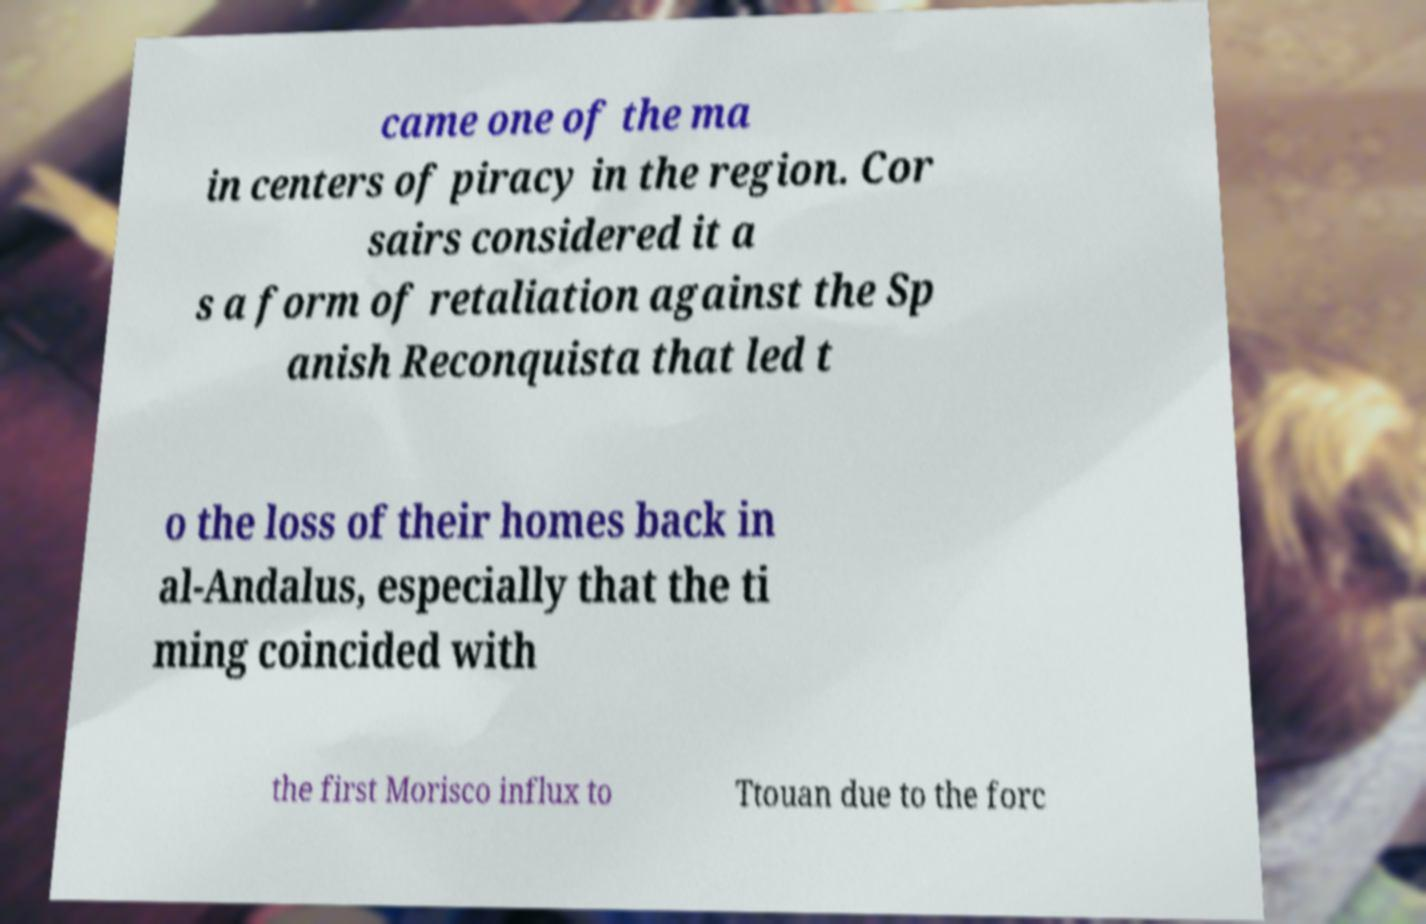Can you read and provide the text displayed in the image?This photo seems to have some interesting text. Can you extract and type it out for me? came one of the ma in centers of piracy in the region. Cor sairs considered it a s a form of retaliation against the Sp anish Reconquista that led t o the loss of their homes back in al-Andalus, especially that the ti ming coincided with the first Morisco influx to Ttouan due to the forc 